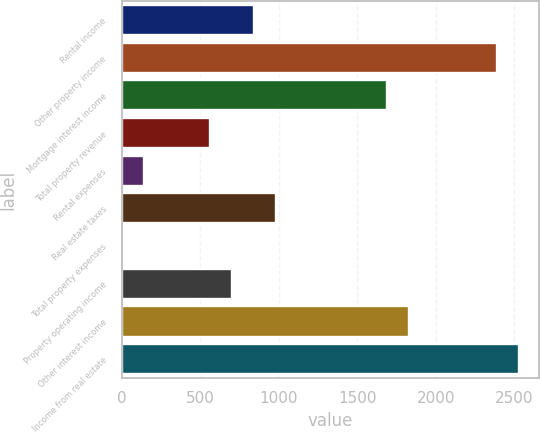Convert chart to OTSL. <chart><loc_0><loc_0><loc_500><loc_500><bar_chart><fcel>Rental income<fcel>Other property income<fcel>Mortgage interest income<fcel>Total property revenue<fcel>Rental expenses<fcel>Real estate taxes<fcel>Total property expenses<fcel>Property operating income<fcel>Other interest income<fcel>Income from real estate<nl><fcel>844.74<fcel>2392.33<fcel>1688.88<fcel>563.36<fcel>141.29<fcel>985.43<fcel>0.6<fcel>704.05<fcel>1829.57<fcel>2533.02<nl></chart> 